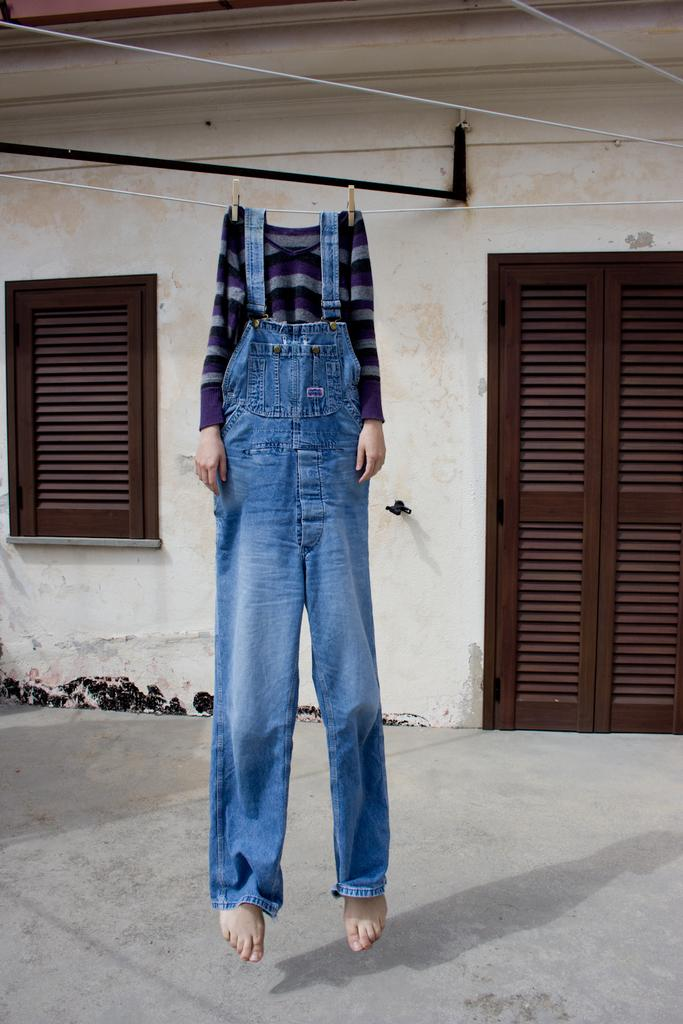What is the main subject of the image? There is a person in the image. What type of clothing is the person wearing? The person is wearing a t-shirt and jeans. What is the person doing in the image? The person is hanging from a pipe. What can be seen in the background of the image? There is a door and windows visible in the background. Can you see a duck in the image? No, there is no duck present in the image. Is there a picture of a robin hanging on the wall in the image? There is no mention of a picture or a robin in the image, so we cannot confirm its presence. 